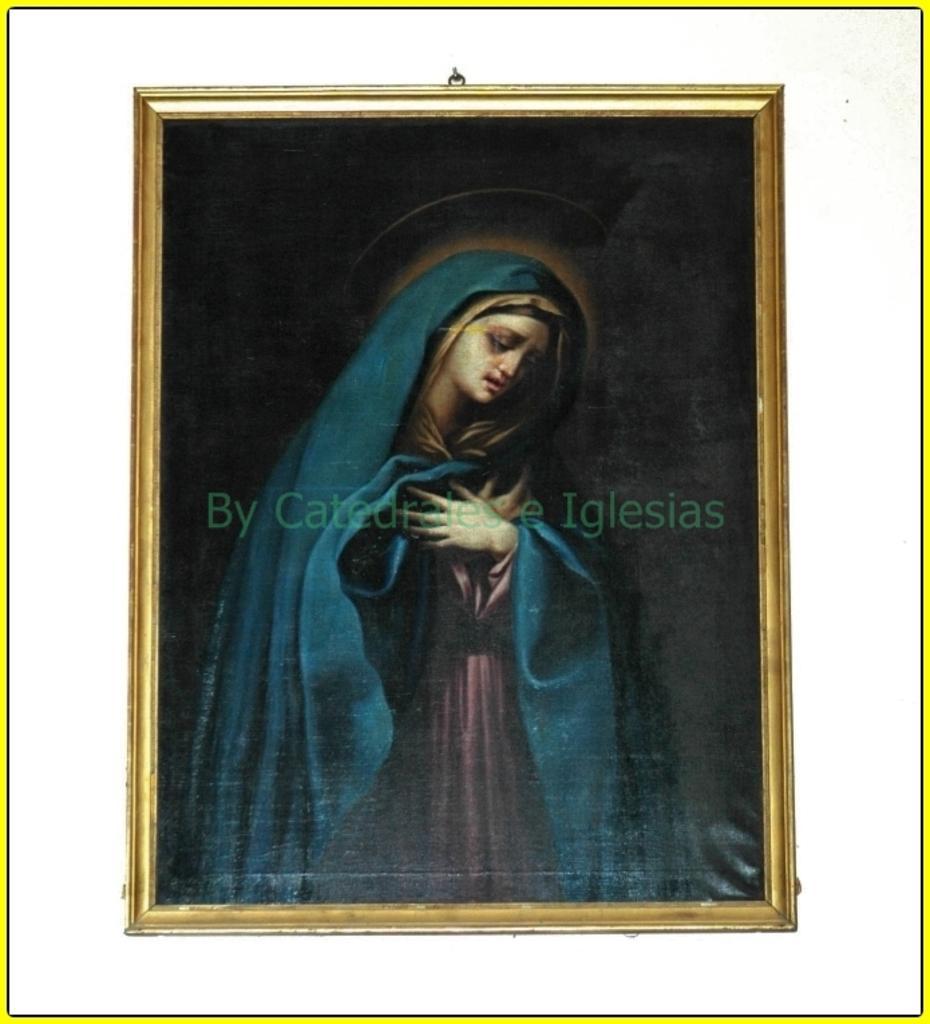Please provide a concise description of this image. In the center of the picture there is a frame, in the frame reach a person. In the center of the picture there is text. 